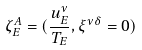Convert formula to latex. <formula><loc_0><loc_0><loc_500><loc_500>\zeta ^ { A } _ { E } = ( \frac { u ^ { \nu } _ { E } } { T _ { E } } , \xi ^ { \nu \delta } = 0 )</formula> 